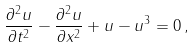<formula> <loc_0><loc_0><loc_500><loc_500>\frac { \partial ^ { 2 } u } { \partial t ^ { 2 } } - \frac { \partial ^ { 2 } u } { \partial x ^ { 2 } } + u - u ^ { 3 } = 0 \, ,</formula> 